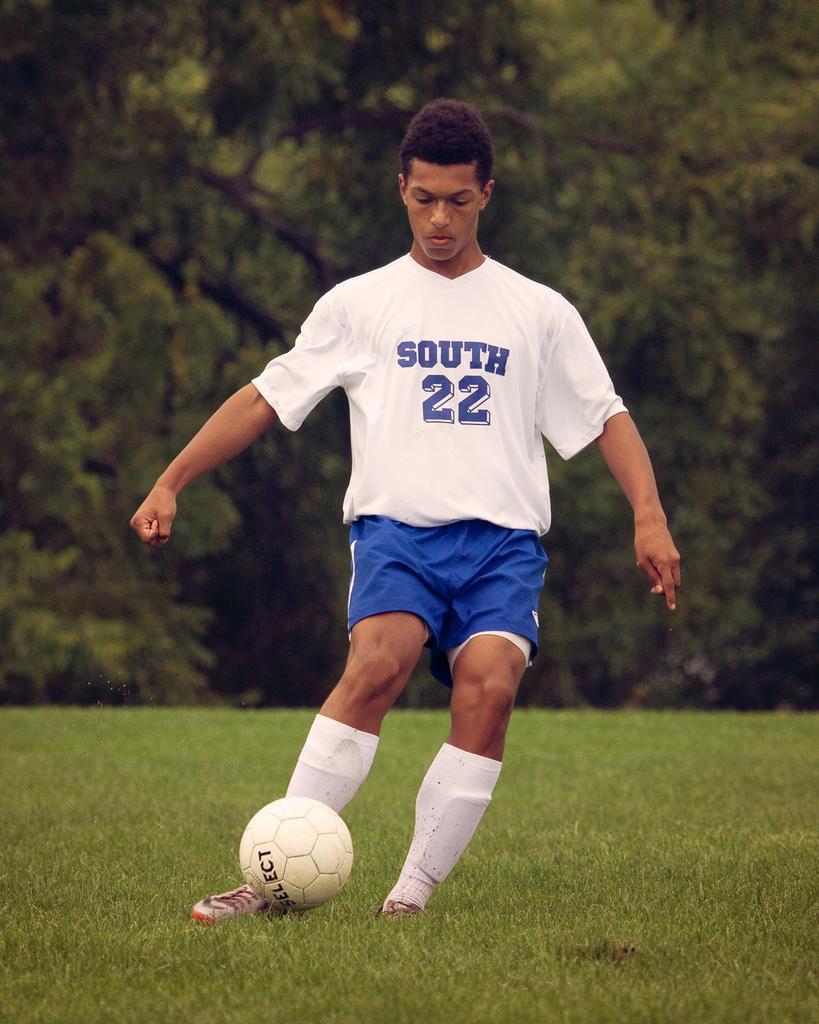Can you describe this image briefly? In this image there is a man with t-shirt and he is playing. At the back there are trees and at the bottom there is a grass. 